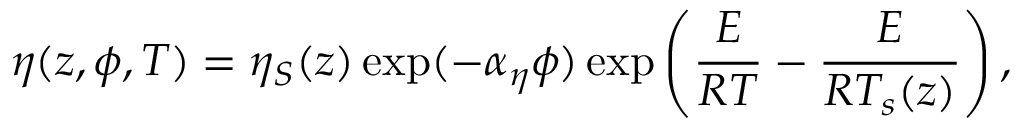Convert formula to latex. <formula><loc_0><loc_0><loc_500><loc_500>\eta ( z , \phi , T ) = \eta _ { S } ( z ) \exp ( - \alpha _ { \eta } \phi ) \exp \left ( \frac { E } { R T } - \frac { E } { R T _ { s } ( z ) } \right ) ,</formula> 